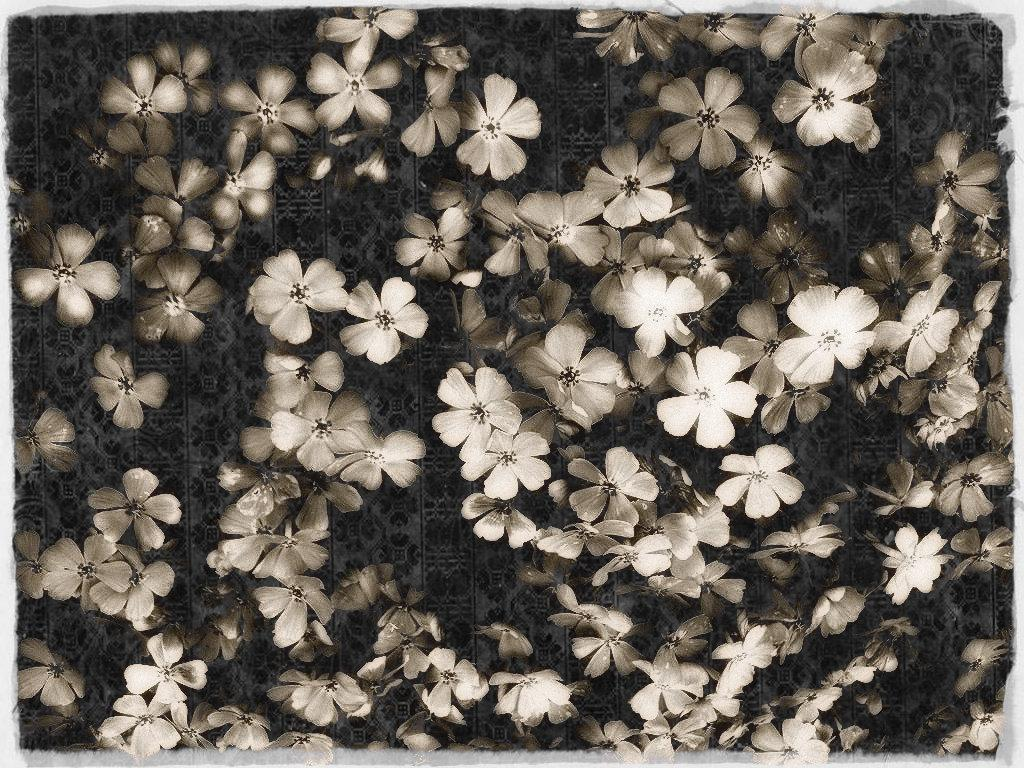What is the main object in the image? There is a cloth in the image. What color is the cloth? The cloth is black in color. Are there any designs or patterns on the cloth? Yes, there are white color flowers designed on the cloth. How many people are in the crowd surrounding the cloth in the image? There is no crowd present in the image; it only features a cloth with white color flowers designed on it. What type of glass is used to create the flowers on the cloth? The flowers on the cloth are not made of glass; they are designed using white color on the black cloth. 